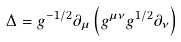<formula> <loc_0><loc_0><loc_500><loc_500>\Delta = g ^ { - 1 / 2 } \partial _ { \mu } \left ( g ^ { \mu \nu } g ^ { 1 / 2 } \partial _ { \nu } \right )</formula> 